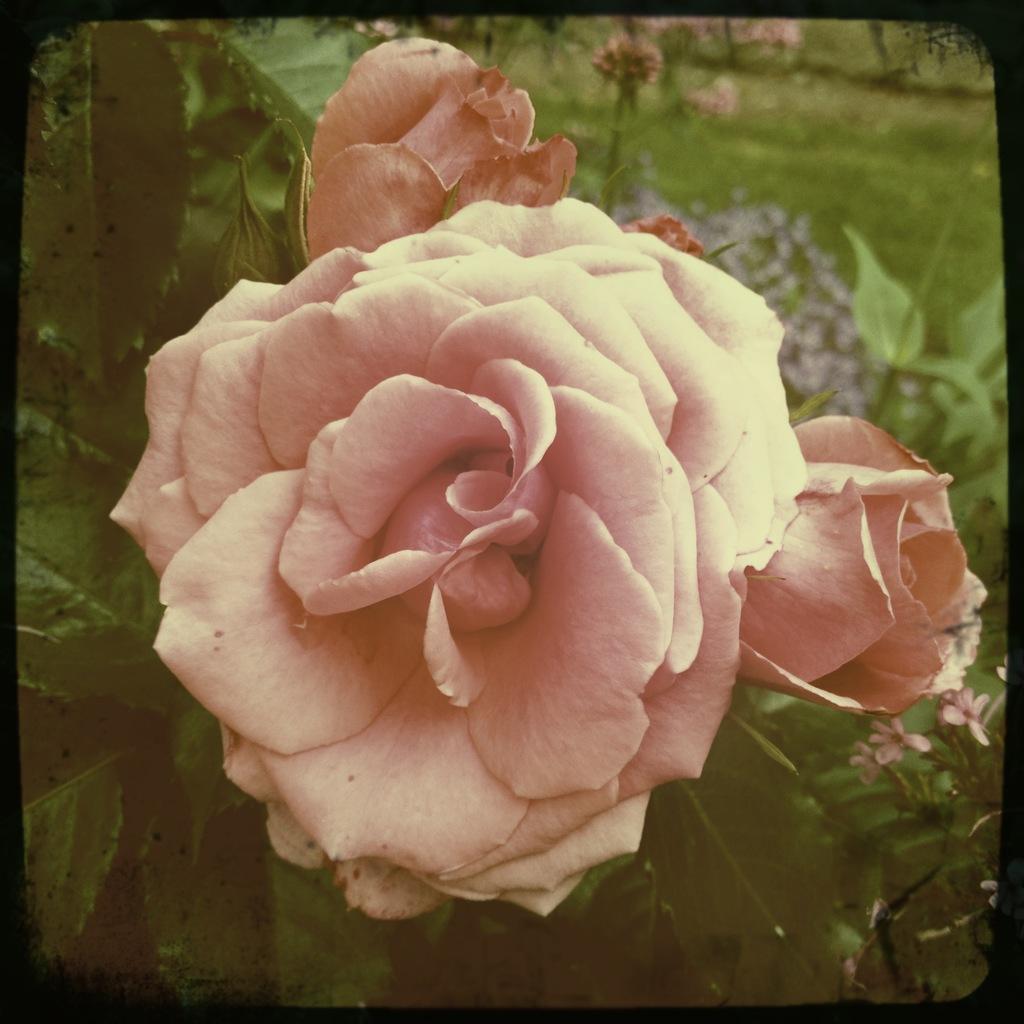Describe this image in one or two sentences. In this image we can see a pink color flower and leaves. 